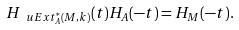Convert formula to latex. <formula><loc_0><loc_0><loc_500><loc_500>H _ { \ u E x t ^ { * } _ { A } ( M , k ) } ( t ) H _ { A } ( - t ) = H _ { M } ( - t ) .</formula> 